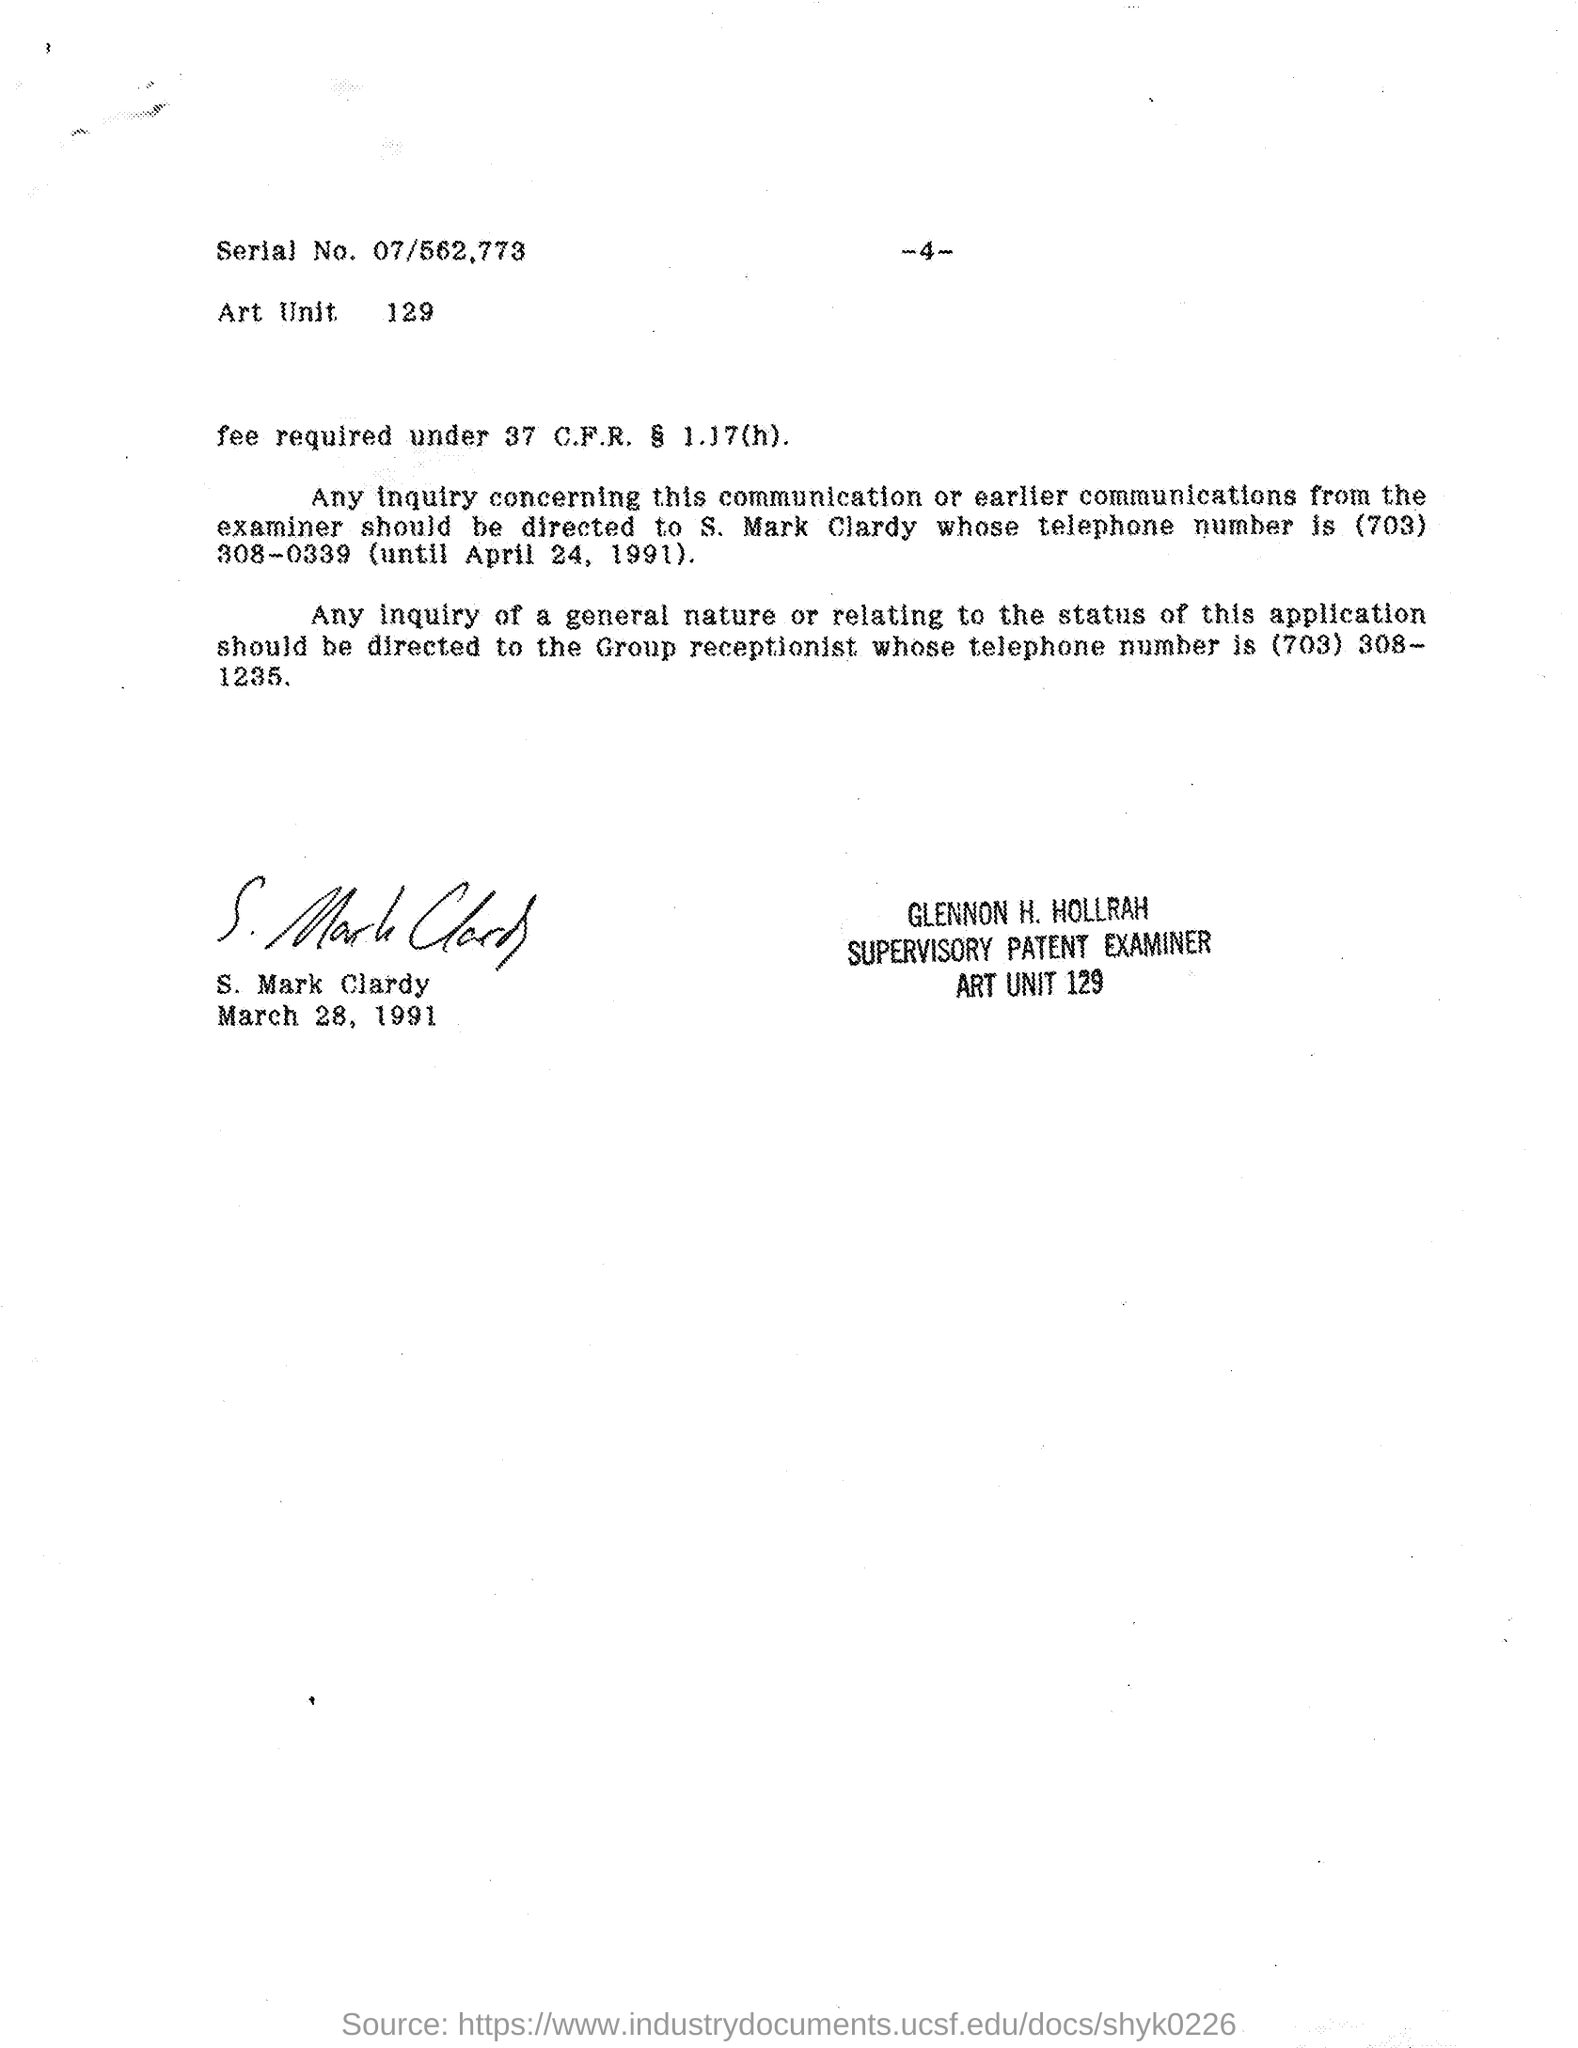Draw attention to some important aspects in this diagram. The telephone number of the group receptionist mentioned in the given letter is (703) 308-1235. The art unit number mentioned in the given page is 129. The telephone number of S. Mark Clardy mentioned in the given page is (703) 308-0339. The letter concluded with the sign "S. Mark Clardy. Glennon H. Hollrah is a supervisory patent examiner. 